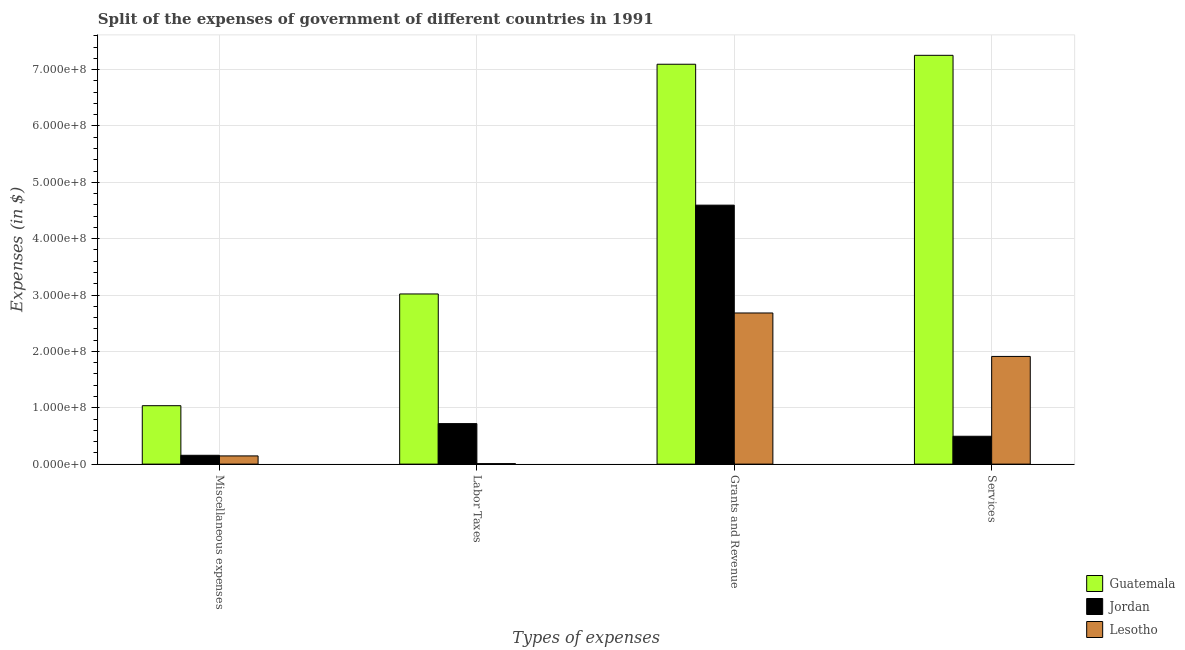How many groups of bars are there?
Keep it short and to the point. 4. Are the number of bars on each tick of the X-axis equal?
Provide a short and direct response. Yes. How many bars are there on the 2nd tick from the right?
Keep it short and to the point. 3. What is the label of the 1st group of bars from the left?
Give a very brief answer. Miscellaneous expenses. What is the amount spent on labor taxes in Jordan?
Your answer should be very brief. 7.18e+07. Across all countries, what is the maximum amount spent on miscellaneous expenses?
Ensure brevity in your answer.  1.04e+08. Across all countries, what is the minimum amount spent on grants and revenue?
Your response must be concise. 2.68e+08. In which country was the amount spent on services maximum?
Keep it short and to the point. Guatemala. In which country was the amount spent on labor taxes minimum?
Offer a terse response. Lesotho. What is the total amount spent on services in the graph?
Ensure brevity in your answer.  9.66e+08. What is the difference between the amount spent on services in Jordan and that in Guatemala?
Give a very brief answer. -6.76e+08. What is the difference between the amount spent on grants and revenue in Jordan and the amount spent on services in Guatemala?
Make the answer very short. -2.66e+08. What is the average amount spent on grants and revenue per country?
Ensure brevity in your answer.  4.79e+08. What is the difference between the amount spent on miscellaneous expenses and amount spent on services in Lesotho?
Give a very brief answer. -1.77e+08. What is the ratio of the amount spent on labor taxes in Jordan to that in Guatemala?
Your answer should be very brief. 0.24. What is the difference between the highest and the second highest amount spent on labor taxes?
Your answer should be very brief. 2.30e+08. What is the difference between the highest and the lowest amount spent on labor taxes?
Your answer should be compact. 3.01e+08. Is the sum of the amount spent on services in Lesotho and Jordan greater than the maximum amount spent on miscellaneous expenses across all countries?
Provide a short and direct response. Yes. Is it the case that in every country, the sum of the amount spent on labor taxes and amount spent on grants and revenue is greater than the sum of amount spent on services and amount spent on miscellaneous expenses?
Provide a succinct answer. Yes. What does the 2nd bar from the left in Miscellaneous expenses represents?
Offer a terse response. Jordan. What does the 3rd bar from the right in Grants and Revenue represents?
Offer a very short reply. Guatemala. What is the difference between two consecutive major ticks on the Y-axis?
Offer a terse response. 1.00e+08. Does the graph contain any zero values?
Offer a terse response. No. Does the graph contain grids?
Provide a short and direct response. Yes. Where does the legend appear in the graph?
Make the answer very short. Bottom right. What is the title of the graph?
Give a very brief answer. Split of the expenses of government of different countries in 1991. Does "Poland" appear as one of the legend labels in the graph?
Your answer should be compact. No. What is the label or title of the X-axis?
Your answer should be compact. Types of expenses. What is the label or title of the Y-axis?
Provide a short and direct response. Expenses (in $). What is the Expenses (in $) of Guatemala in Miscellaneous expenses?
Offer a very short reply. 1.04e+08. What is the Expenses (in $) of Jordan in Miscellaneous expenses?
Give a very brief answer. 1.57e+07. What is the Expenses (in $) of Lesotho in Miscellaneous expenses?
Offer a very short reply. 1.46e+07. What is the Expenses (in $) in Guatemala in Labor Taxes?
Your response must be concise. 3.02e+08. What is the Expenses (in $) in Jordan in Labor Taxes?
Ensure brevity in your answer.  7.18e+07. What is the Expenses (in $) of Lesotho in Labor Taxes?
Ensure brevity in your answer.  8.87e+05. What is the Expenses (in $) in Guatemala in Grants and Revenue?
Offer a terse response. 7.09e+08. What is the Expenses (in $) of Jordan in Grants and Revenue?
Offer a terse response. 4.59e+08. What is the Expenses (in $) in Lesotho in Grants and Revenue?
Offer a terse response. 2.68e+08. What is the Expenses (in $) of Guatemala in Services?
Keep it short and to the point. 7.25e+08. What is the Expenses (in $) in Jordan in Services?
Provide a short and direct response. 4.94e+07. What is the Expenses (in $) of Lesotho in Services?
Keep it short and to the point. 1.91e+08. Across all Types of expenses, what is the maximum Expenses (in $) in Guatemala?
Keep it short and to the point. 7.25e+08. Across all Types of expenses, what is the maximum Expenses (in $) in Jordan?
Offer a terse response. 4.59e+08. Across all Types of expenses, what is the maximum Expenses (in $) in Lesotho?
Your response must be concise. 2.68e+08. Across all Types of expenses, what is the minimum Expenses (in $) in Guatemala?
Offer a terse response. 1.04e+08. Across all Types of expenses, what is the minimum Expenses (in $) of Jordan?
Ensure brevity in your answer.  1.57e+07. Across all Types of expenses, what is the minimum Expenses (in $) of Lesotho?
Provide a succinct answer. 8.87e+05. What is the total Expenses (in $) in Guatemala in the graph?
Your answer should be compact. 1.84e+09. What is the total Expenses (in $) in Jordan in the graph?
Provide a short and direct response. 5.96e+08. What is the total Expenses (in $) in Lesotho in the graph?
Make the answer very short. 4.75e+08. What is the difference between the Expenses (in $) of Guatemala in Miscellaneous expenses and that in Labor Taxes?
Make the answer very short. -1.98e+08. What is the difference between the Expenses (in $) of Jordan in Miscellaneous expenses and that in Labor Taxes?
Your answer should be compact. -5.62e+07. What is the difference between the Expenses (in $) of Lesotho in Miscellaneous expenses and that in Labor Taxes?
Give a very brief answer. 1.37e+07. What is the difference between the Expenses (in $) in Guatemala in Miscellaneous expenses and that in Grants and Revenue?
Offer a terse response. -6.06e+08. What is the difference between the Expenses (in $) of Jordan in Miscellaneous expenses and that in Grants and Revenue?
Your answer should be very brief. -4.44e+08. What is the difference between the Expenses (in $) of Lesotho in Miscellaneous expenses and that in Grants and Revenue?
Your response must be concise. -2.54e+08. What is the difference between the Expenses (in $) of Guatemala in Miscellaneous expenses and that in Services?
Provide a succinct answer. -6.22e+08. What is the difference between the Expenses (in $) of Jordan in Miscellaneous expenses and that in Services?
Make the answer very short. -3.38e+07. What is the difference between the Expenses (in $) in Lesotho in Miscellaneous expenses and that in Services?
Your answer should be compact. -1.77e+08. What is the difference between the Expenses (in $) of Guatemala in Labor Taxes and that in Grants and Revenue?
Your answer should be very brief. -4.08e+08. What is the difference between the Expenses (in $) in Jordan in Labor Taxes and that in Grants and Revenue?
Make the answer very short. -3.88e+08. What is the difference between the Expenses (in $) in Lesotho in Labor Taxes and that in Grants and Revenue?
Ensure brevity in your answer.  -2.67e+08. What is the difference between the Expenses (in $) in Guatemala in Labor Taxes and that in Services?
Offer a terse response. -4.23e+08. What is the difference between the Expenses (in $) in Jordan in Labor Taxes and that in Services?
Make the answer very short. 2.24e+07. What is the difference between the Expenses (in $) in Lesotho in Labor Taxes and that in Services?
Your answer should be compact. -1.90e+08. What is the difference between the Expenses (in $) in Guatemala in Grants and Revenue and that in Services?
Offer a very short reply. -1.58e+07. What is the difference between the Expenses (in $) of Jordan in Grants and Revenue and that in Services?
Your answer should be very brief. 4.10e+08. What is the difference between the Expenses (in $) of Lesotho in Grants and Revenue and that in Services?
Your answer should be very brief. 7.71e+07. What is the difference between the Expenses (in $) of Guatemala in Miscellaneous expenses and the Expenses (in $) of Jordan in Labor Taxes?
Give a very brief answer. 3.18e+07. What is the difference between the Expenses (in $) of Guatemala in Miscellaneous expenses and the Expenses (in $) of Lesotho in Labor Taxes?
Offer a very short reply. 1.03e+08. What is the difference between the Expenses (in $) of Jordan in Miscellaneous expenses and the Expenses (in $) of Lesotho in Labor Taxes?
Your answer should be very brief. 1.48e+07. What is the difference between the Expenses (in $) in Guatemala in Miscellaneous expenses and the Expenses (in $) in Jordan in Grants and Revenue?
Offer a very short reply. -3.56e+08. What is the difference between the Expenses (in $) in Guatemala in Miscellaneous expenses and the Expenses (in $) in Lesotho in Grants and Revenue?
Give a very brief answer. -1.64e+08. What is the difference between the Expenses (in $) in Jordan in Miscellaneous expenses and the Expenses (in $) in Lesotho in Grants and Revenue?
Keep it short and to the point. -2.52e+08. What is the difference between the Expenses (in $) in Guatemala in Miscellaneous expenses and the Expenses (in $) in Jordan in Services?
Your response must be concise. 5.42e+07. What is the difference between the Expenses (in $) in Guatemala in Miscellaneous expenses and the Expenses (in $) in Lesotho in Services?
Give a very brief answer. -8.74e+07. What is the difference between the Expenses (in $) in Jordan in Miscellaneous expenses and the Expenses (in $) in Lesotho in Services?
Offer a very short reply. -1.75e+08. What is the difference between the Expenses (in $) of Guatemala in Labor Taxes and the Expenses (in $) of Jordan in Grants and Revenue?
Offer a terse response. -1.58e+08. What is the difference between the Expenses (in $) in Guatemala in Labor Taxes and the Expenses (in $) in Lesotho in Grants and Revenue?
Make the answer very short. 3.37e+07. What is the difference between the Expenses (in $) in Jordan in Labor Taxes and the Expenses (in $) in Lesotho in Grants and Revenue?
Provide a short and direct response. -1.96e+08. What is the difference between the Expenses (in $) in Guatemala in Labor Taxes and the Expenses (in $) in Jordan in Services?
Offer a very short reply. 2.52e+08. What is the difference between the Expenses (in $) in Guatemala in Labor Taxes and the Expenses (in $) in Lesotho in Services?
Your answer should be compact. 1.11e+08. What is the difference between the Expenses (in $) of Jordan in Labor Taxes and the Expenses (in $) of Lesotho in Services?
Your answer should be very brief. -1.19e+08. What is the difference between the Expenses (in $) of Guatemala in Grants and Revenue and the Expenses (in $) of Jordan in Services?
Keep it short and to the point. 6.60e+08. What is the difference between the Expenses (in $) in Guatemala in Grants and Revenue and the Expenses (in $) in Lesotho in Services?
Your answer should be very brief. 5.18e+08. What is the difference between the Expenses (in $) of Jordan in Grants and Revenue and the Expenses (in $) of Lesotho in Services?
Your answer should be compact. 2.68e+08. What is the average Expenses (in $) in Guatemala per Types of expenses?
Provide a succinct answer. 4.60e+08. What is the average Expenses (in $) of Jordan per Types of expenses?
Your response must be concise. 1.49e+08. What is the average Expenses (in $) in Lesotho per Types of expenses?
Your response must be concise. 1.19e+08. What is the difference between the Expenses (in $) in Guatemala and Expenses (in $) in Jordan in Miscellaneous expenses?
Offer a terse response. 8.80e+07. What is the difference between the Expenses (in $) of Guatemala and Expenses (in $) of Lesotho in Miscellaneous expenses?
Provide a short and direct response. 8.91e+07. What is the difference between the Expenses (in $) in Jordan and Expenses (in $) in Lesotho in Miscellaneous expenses?
Offer a very short reply. 1.11e+06. What is the difference between the Expenses (in $) in Guatemala and Expenses (in $) in Jordan in Labor Taxes?
Make the answer very short. 2.30e+08. What is the difference between the Expenses (in $) in Guatemala and Expenses (in $) in Lesotho in Labor Taxes?
Your answer should be very brief. 3.01e+08. What is the difference between the Expenses (in $) of Jordan and Expenses (in $) of Lesotho in Labor Taxes?
Ensure brevity in your answer.  7.10e+07. What is the difference between the Expenses (in $) of Guatemala and Expenses (in $) of Jordan in Grants and Revenue?
Keep it short and to the point. 2.50e+08. What is the difference between the Expenses (in $) in Guatemala and Expenses (in $) in Lesotho in Grants and Revenue?
Offer a terse response. 4.41e+08. What is the difference between the Expenses (in $) of Jordan and Expenses (in $) of Lesotho in Grants and Revenue?
Give a very brief answer. 1.91e+08. What is the difference between the Expenses (in $) in Guatemala and Expenses (in $) in Jordan in Services?
Provide a succinct answer. 6.76e+08. What is the difference between the Expenses (in $) of Guatemala and Expenses (in $) of Lesotho in Services?
Make the answer very short. 5.34e+08. What is the difference between the Expenses (in $) in Jordan and Expenses (in $) in Lesotho in Services?
Provide a succinct answer. -1.42e+08. What is the ratio of the Expenses (in $) of Guatemala in Miscellaneous expenses to that in Labor Taxes?
Make the answer very short. 0.34. What is the ratio of the Expenses (in $) in Jordan in Miscellaneous expenses to that in Labor Taxes?
Make the answer very short. 0.22. What is the ratio of the Expenses (in $) in Lesotho in Miscellaneous expenses to that in Labor Taxes?
Your answer should be very brief. 16.4. What is the ratio of the Expenses (in $) of Guatemala in Miscellaneous expenses to that in Grants and Revenue?
Give a very brief answer. 0.15. What is the ratio of the Expenses (in $) of Jordan in Miscellaneous expenses to that in Grants and Revenue?
Give a very brief answer. 0.03. What is the ratio of the Expenses (in $) in Lesotho in Miscellaneous expenses to that in Grants and Revenue?
Offer a very short reply. 0.05. What is the ratio of the Expenses (in $) in Guatemala in Miscellaneous expenses to that in Services?
Your answer should be very brief. 0.14. What is the ratio of the Expenses (in $) of Jordan in Miscellaneous expenses to that in Services?
Your answer should be very brief. 0.32. What is the ratio of the Expenses (in $) of Lesotho in Miscellaneous expenses to that in Services?
Ensure brevity in your answer.  0.08. What is the ratio of the Expenses (in $) in Guatemala in Labor Taxes to that in Grants and Revenue?
Provide a short and direct response. 0.43. What is the ratio of the Expenses (in $) of Jordan in Labor Taxes to that in Grants and Revenue?
Provide a succinct answer. 0.16. What is the ratio of the Expenses (in $) of Lesotho in Labor Taxes to that in Grants and Revenue?
Offer a terse response. 0. What is the ratio of the Expenses (in $) of Guatemala in Labor Taxes to that in Services?
Your response must be concise. 0.42. What is the ratio of the Expenses (in $) in Jordan in Labor Taxes to that in Services?
Your response must be concise. 1.45. What is the ratio of the Expenses (in $) of Lesotho in Labor Taxes to that in Services?
Keep it short and to the point. 0. What is the ratio of the Expenses (in $) of Guatemala in Grants and Revenue to that in Services?
Provide a short and direct response. 0.98. What is the ratio of the Expenses (in $) of Jordan in Grants and Revenue to that in Services?
Your answer should be very brief. 9.3. What is the ratio of the Expenses (in $) in Lesotho in Grants and Revenue to that in Services?
Your answer should be very brief. 1.4. What is the difference between the highest and the second highest Expenses (in $) of Guatemala?
Keep it short and to the point. 1.58e+07. What is the difference between the highest and the second highest Expenses (in $) of Jordan?
Keep it short and to the point. 3.88e+08. What is the difference between the highest and the second highest Expenses (in $) of Lesotho?
Keep it short and to the point. 7.71e+07. What is the difference between the highest and the lowest Expenses (in $) in Guatemala?
Offer a very short reply. 6.22e+08. What is the difference between the highest and the lowest Expenses (in $) of Jordan?
Give a very brief answer. 4.44e+08. What is the difference between the highest and the lowest Expenses (in $) of Lesotho?
Provide a short and direct response. 2.67e+08. 